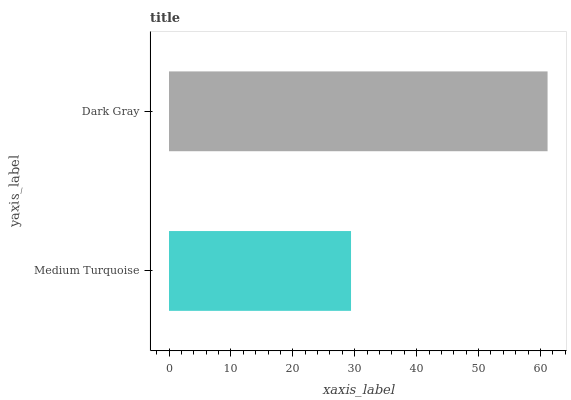Is Medium Turquoise the minimum?
Answer yes or no. Yes. Is Dark Gray the maximum?
Answer yes or no. Yes. Is Dark Gray the minimum?
Answer yes or no. No. Is Dark Gray greater than Medium Turquoise?
Answer yes or no. Yes. Is Medium Turquoise less than Dark Gray?
Answer yes or no. Yes. Is Medium Turquoise greater than Dark Gray?
Answer yes or no. No. Is Dark Gray less than Medium Turquoise?
Answer yes or no. No. Is Dark Gray the high median?
Answer yes or no. Yes. Is Medium Turquoise the low median?
Answer yes or no. Yes. Is Medium Turquoise the high median?
Answer yes or no. No. Is Dark Gray the low median?
Answer yes or no. No. 